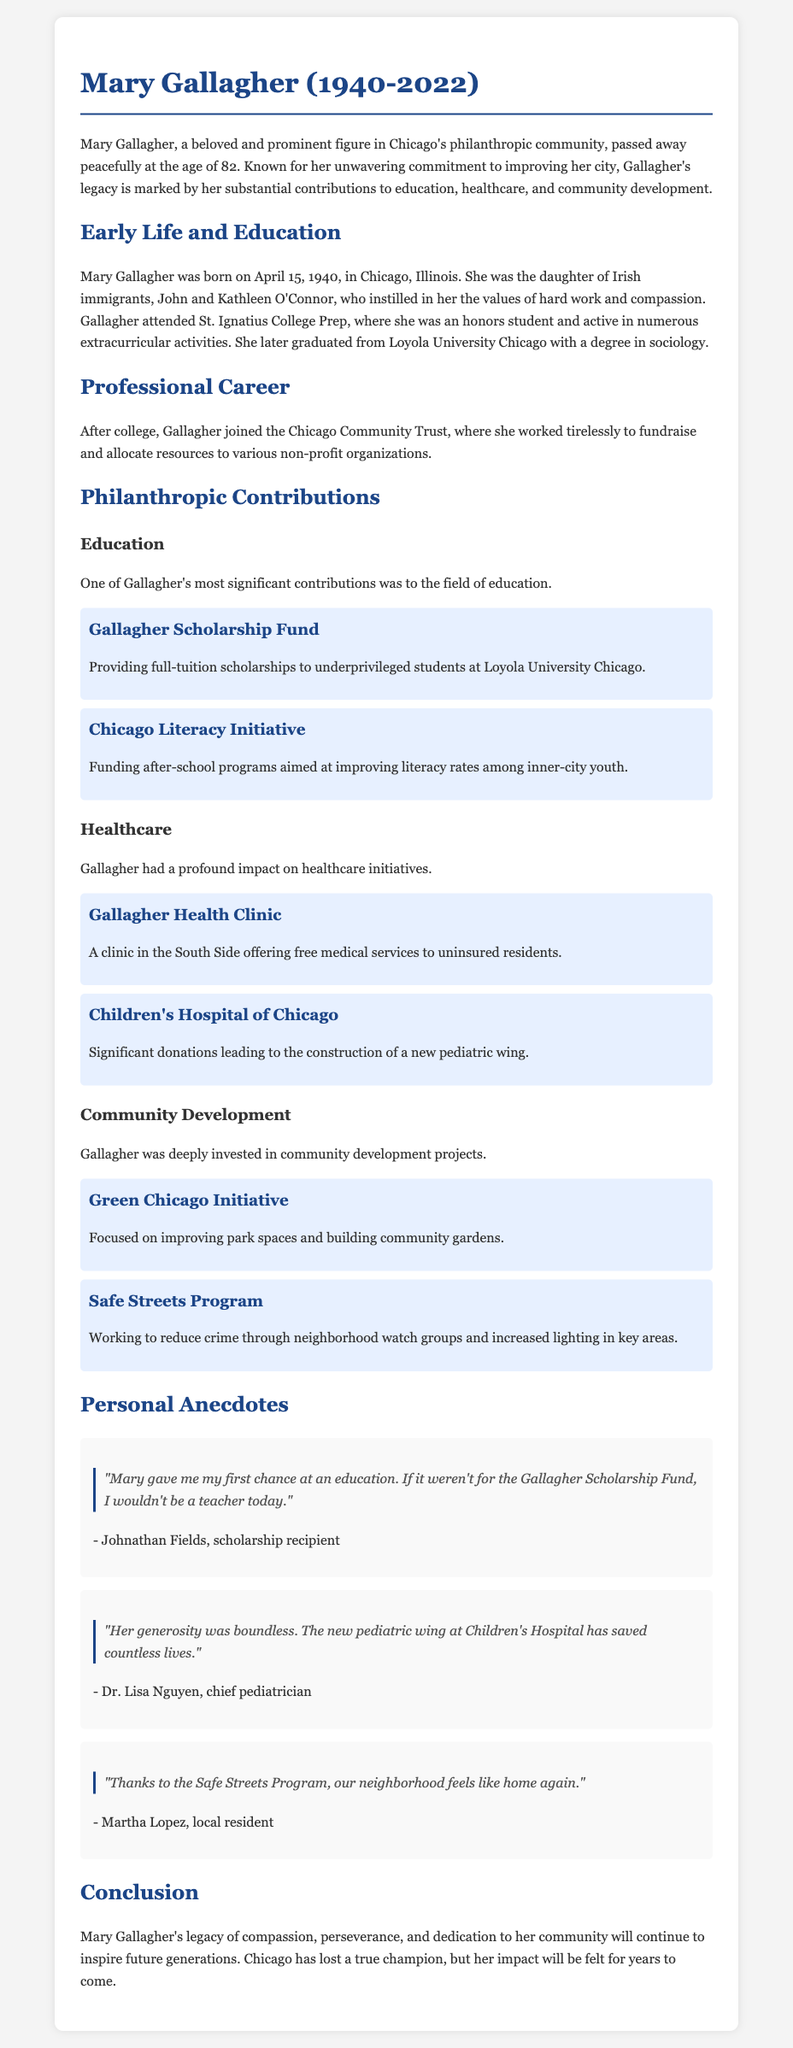What was the birth date of Mary Gallagher? The document states that she was born on April 15, 1940.
Answer: April 15, 1940 How old was Mary Gallagher when she passed away? The document indicates she passed away at the age of 82.
Answer: 82 What degree did Mary Gallagher earn from Loyola University Chicago? The document mentions she graduated with a degree in sociology.
Answer: Sociology Which fund provided full-tuition scholarships to underprivileged students? The document refers to the Gallagher Scholarship Fund.
Answer: Gallagher Scholarship Fund What significant donation did Gallagher make to the Children's Hospital of Chicago? The document states she made significant donations leading to the construction of a new pediatric wing.
Answer: Construction of a new pediatric wing Who was a recipient of the Gallagher Scholarship Fund? The document quotes Johnathan Fields as a scholarship recipient.
Answer: Johnathan Fields What impact did the Safe Streets Program have according to a local resident? According to Martha Lopez, it made the neighborhood feel like home again.
Answer: Like home again What initiative focused on improving park spaces? The document lists the Green Chicago Initiative as the project focused on parks.
Answer: Green Chicago Initiative What did Dr. Lisa Nguyen say about the impact of the new pediatric wing? Dr. Nguyen stated that it has saved countless lives.
Answer: Saved countless lives 